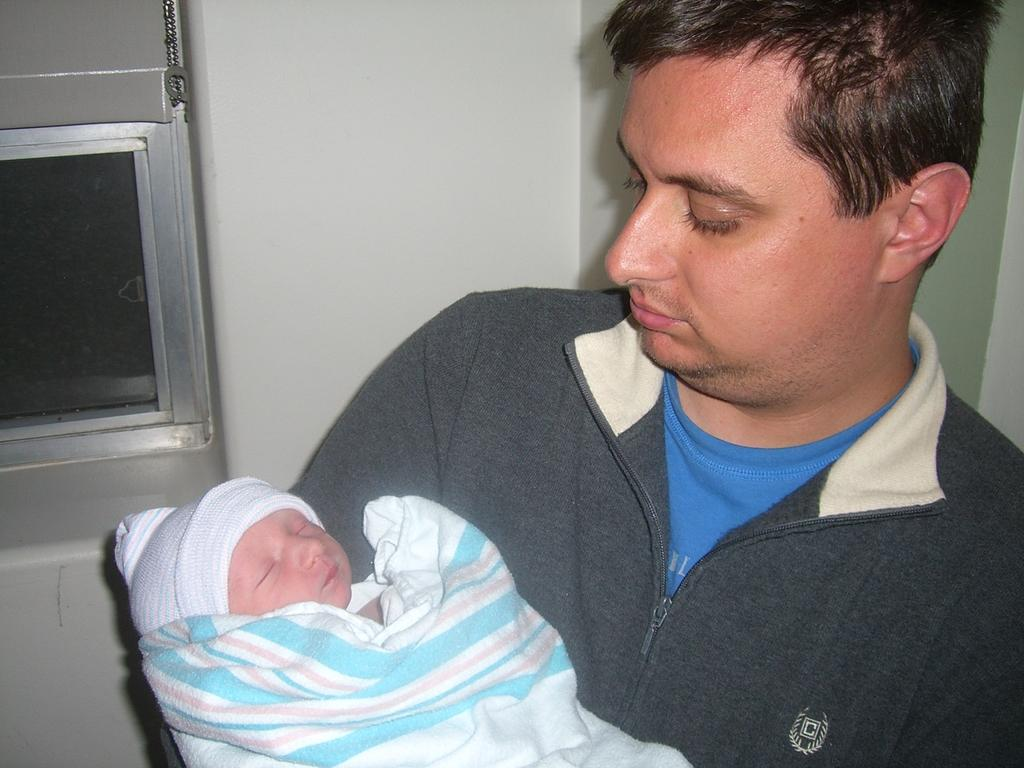What can be found in the left corner of the image? There is a metal object in the left corner of the image. What is happening in the foreground of the image? There is a person carrying a kid in the foreground of the image. What is visible in the background of the image? There is a wall in the background of the image. Where is the bell located in the image? There is no bell present in the image. What type of cake is being served in the image? There is no cake present in the image. 